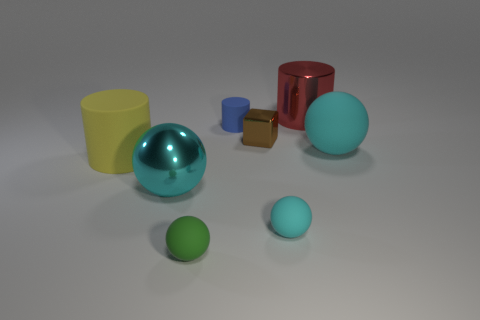Subtract all blue blocks. How many cyan spheres are left? 3 Subtract 1 spheres. How many spheres are left? 3 Subtract all purple balls. Subtract all red cylinders. How many balls are left? 4 Add 2 purple cylinders. How many objects exist? 10 Subtract all cylinders. How many objects are left? 5 Add 4 cyan metal spheres. How many cyan metal spheres exist? 5 Subtract 0 cyan cylinders. How many objects are left? 8 Subtract all large red cylinders. Subtract all yellow cylinders. How many objects are left? 6 Add 8 shiny cylinders. How many shiny cylinders are left? 9 